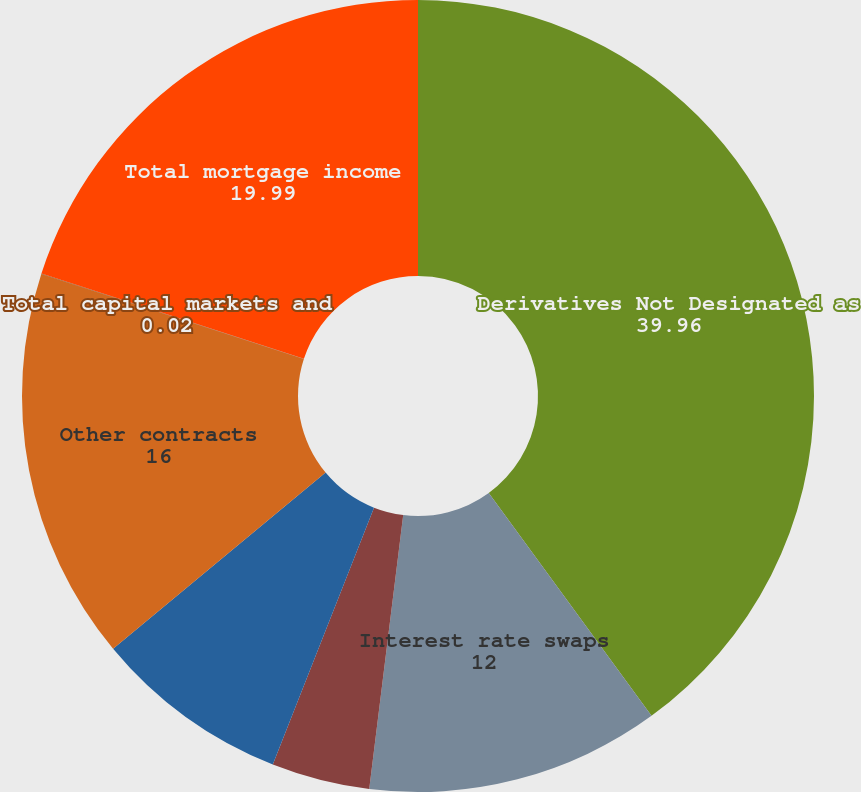<chart> <loc_0><loc_0><loc_500><loc_500><pie_chart><fcel>Derivatives Not Designated as<fcel>Interest rate swaps<fcel>Interest rate options<fcel>Interest rate futures and<fcel>Other contracts<fcel>Total capital markets and<fcel>Total mortgage income<nl><fcel>39.96%<fcel>12.0%<fcel>4.01%<fcel>8.01%<fcel>16.0%<fcel>0.02%<fcel>19.99%<nl></chart> 